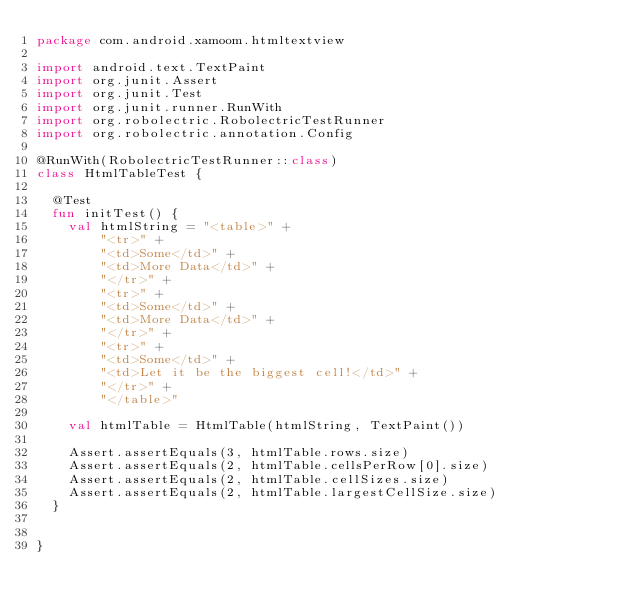<code> <loc_0><loc_0><loc_500><loc_500><_Kotlin_>package com.android.xamoom.htmltextview

import android.text.TextPaint
import org.junit.Assert
import org.junit.Test
import org.junit.runner.RunWith
import org.robolectric.RobolectricTestRunner
import org.robolectric.annotation.Config

@RunWith(RobolectricTestRunner::class)
class HtmlTableTest {

  @Test
  fun initTest() {
    val htmlString = "<table>" +
        "<tr>" +
        "<td>Some</td>" +
        "<td>More Data</td>" +
        "</tr>" +
        "<tr>" +
        "<td>Some</td>" +
        "<td>More Data</td>" +
        "</tr>" +
        "<tr>" +
        "<td>Some</td>" +
        "<td>Let it be the biggest cell!</td>" +
        "</tr>" +
        "</table>"

    val htmlTable = HtmlTable(htmlString, TextPaint())

    Assert.assertEquals(3, htmlTable.rows.size)
    Assert.assertEquals(2, htmlTable.cellsPerRow[0].size)
    Assert.assertEquals(2, htmlTable.cellSizes.size)
    Assert.assertEquals(2, htmlTable.largestCellSize.size)
  }


}</code> 